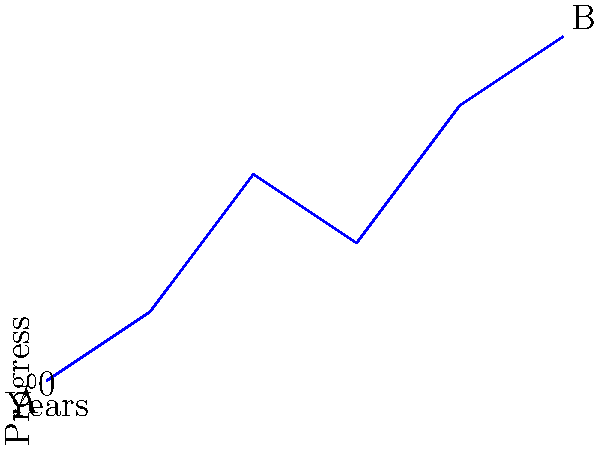The graph represents the progress of peace negotiations over 5 years. Point A (0,0) marks the start, and point B (5,5) marks the end of the negotiations. Calculate the overall slope of the peace process, interpreting its meaning in the context of diplomatic efforts. To calculate the slope of the peace negotiation timeline:

1. Identify the coordinates:
   Point A: (0,0)
   Point B: (5,5)

2. Use the slope formula: $m = \frac{y_2 - y_1}{x_2 - x_1}$

3. Plug in the values:
   $m = \frac{5 - 0}{5 - 0} = \frac{5}{5} = 1$

4. Interpretation:
   - The slope is 1, indicating a positive, steady progress.
   - For each year that passes, there is a corresponding unit increase in progress.
   - This suggests a consistent, balanced approach to negotiations.

5. Diplomatic context:
   - A slope of 1 implies stability and mutual compromise.
   - It reflects a diplomatic process where both parties make equal concessions over time.
   - This steady progress aligns with long-term peace-building efforts, avoiding the use of lawfare tactics.
Answer: Slope = 1; indicates steady, balanced progress in negotiations. 